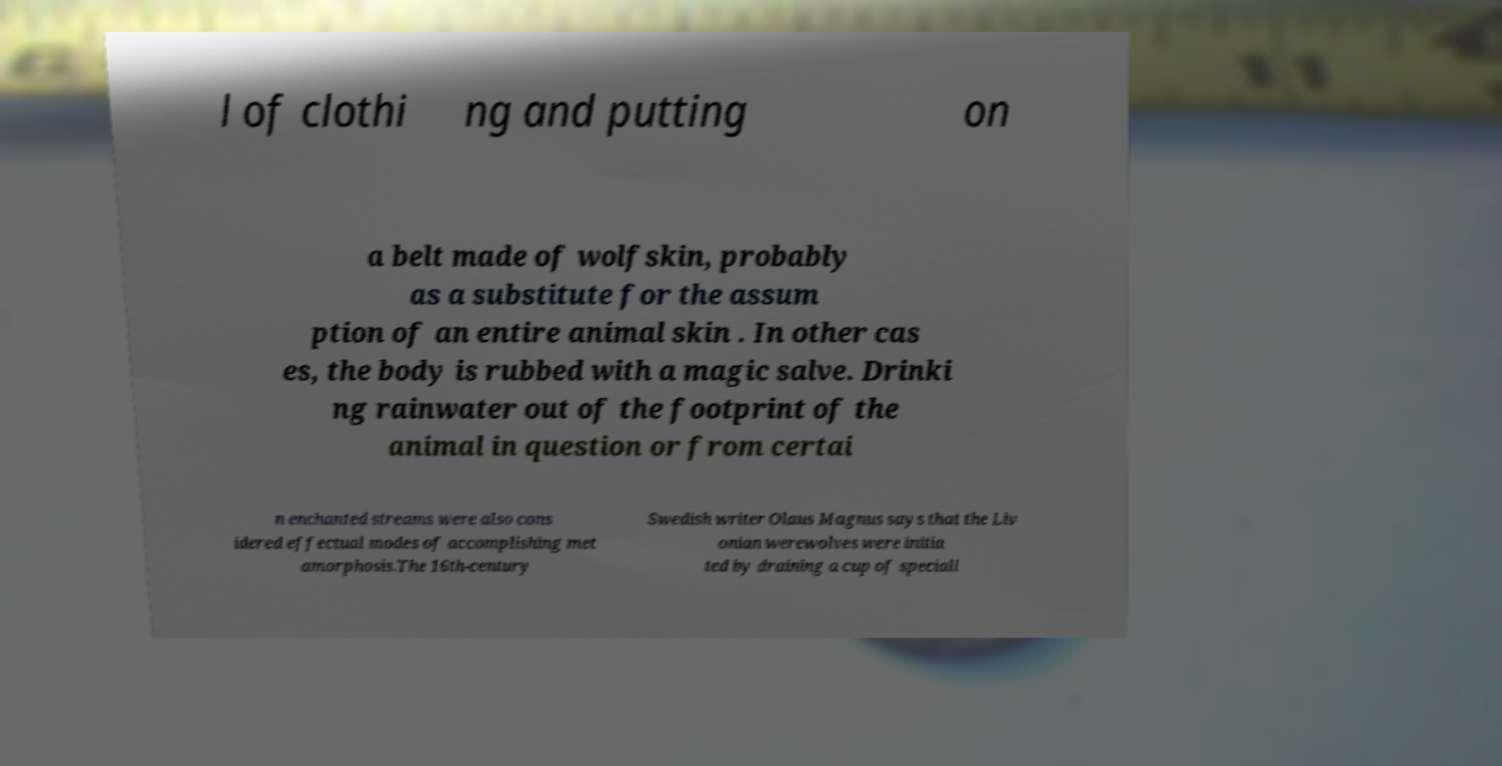I need the written content from this picture converted into text. Can you do that? l of clothi ng and putting on a belt made of wolfskin, probably as a substitute for the assum ption of an entire animal skin . In other cas es, the body is rubbed with a magic salve. Drinki ng rainwater out of the footprint of the animal in question or from certai n enchanted streams were also cons idered effectual modes of accomplishing met amorphosis.The 16th-century Swedish writer Olaus Magnus says that the Liv onian werewolves were initia ted by draining a cup of speciall 